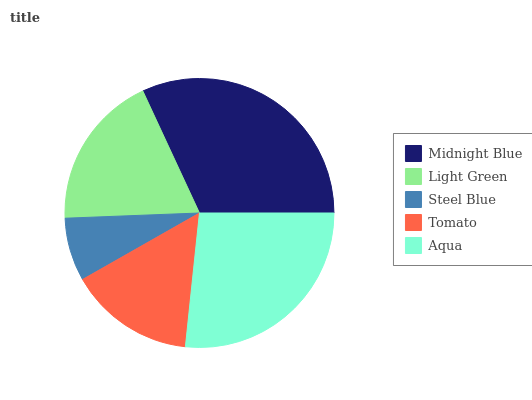Is Steel Blue the minimum?
Answer yes or no. Yes. Is Midnight Blue the maximum?
Answer yes or no. Yes. Is Light Green the minimum?
Answer yes or no. No. Is Light Green the maximum?
Answer yes or no. No. Is Midnight Blue greater than Light Green?
Answer yes or no. Yes. Is Light Green less than Midnight Blue?
Answer yes or no. Yes. Is Light Green greater than Midnight Blue?
Answer yes or no. No. Is Midnight Blue less than Light Green?
Answer yes or no. No. Is Light Green the high median?
Answer yes or no. Yes. Is Light Green the low median?
Answer yes or no. Yes. Is Steel Blue the high median?
Answer yes or no. No. Is Tomato the low median?
Answer yes or no. No. 